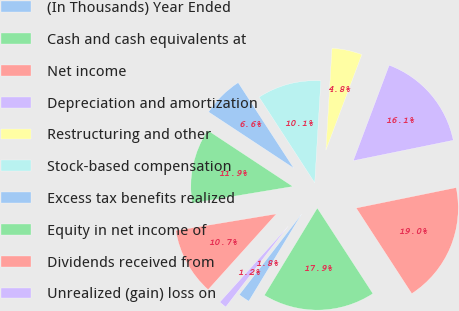<chart> <loc_0><loc_0><loc_500><loc_500><pie_chart><fcel>(In Thousands) Year Ended<fcel>Cash and cash equivalents at<fcel>Net income<fcel>Depreciation and amortization<fcel>Restructuring and other<fcel>Stock-based compensation<fcel>Excess tax benefits realized<fcel>Equity in net income of<fcel>Dividends received from<fcel>Unrealized (gain) loss on<nl><fcel>1.79%<fcel>17.85%<fcel>19.04%<fcel>16.07%<fcel>4.77%<fcel>10.12%<fcel>6.55%<fcel>11.9%<fcel>10.71%<fcel>1.2%<nl></chart> 